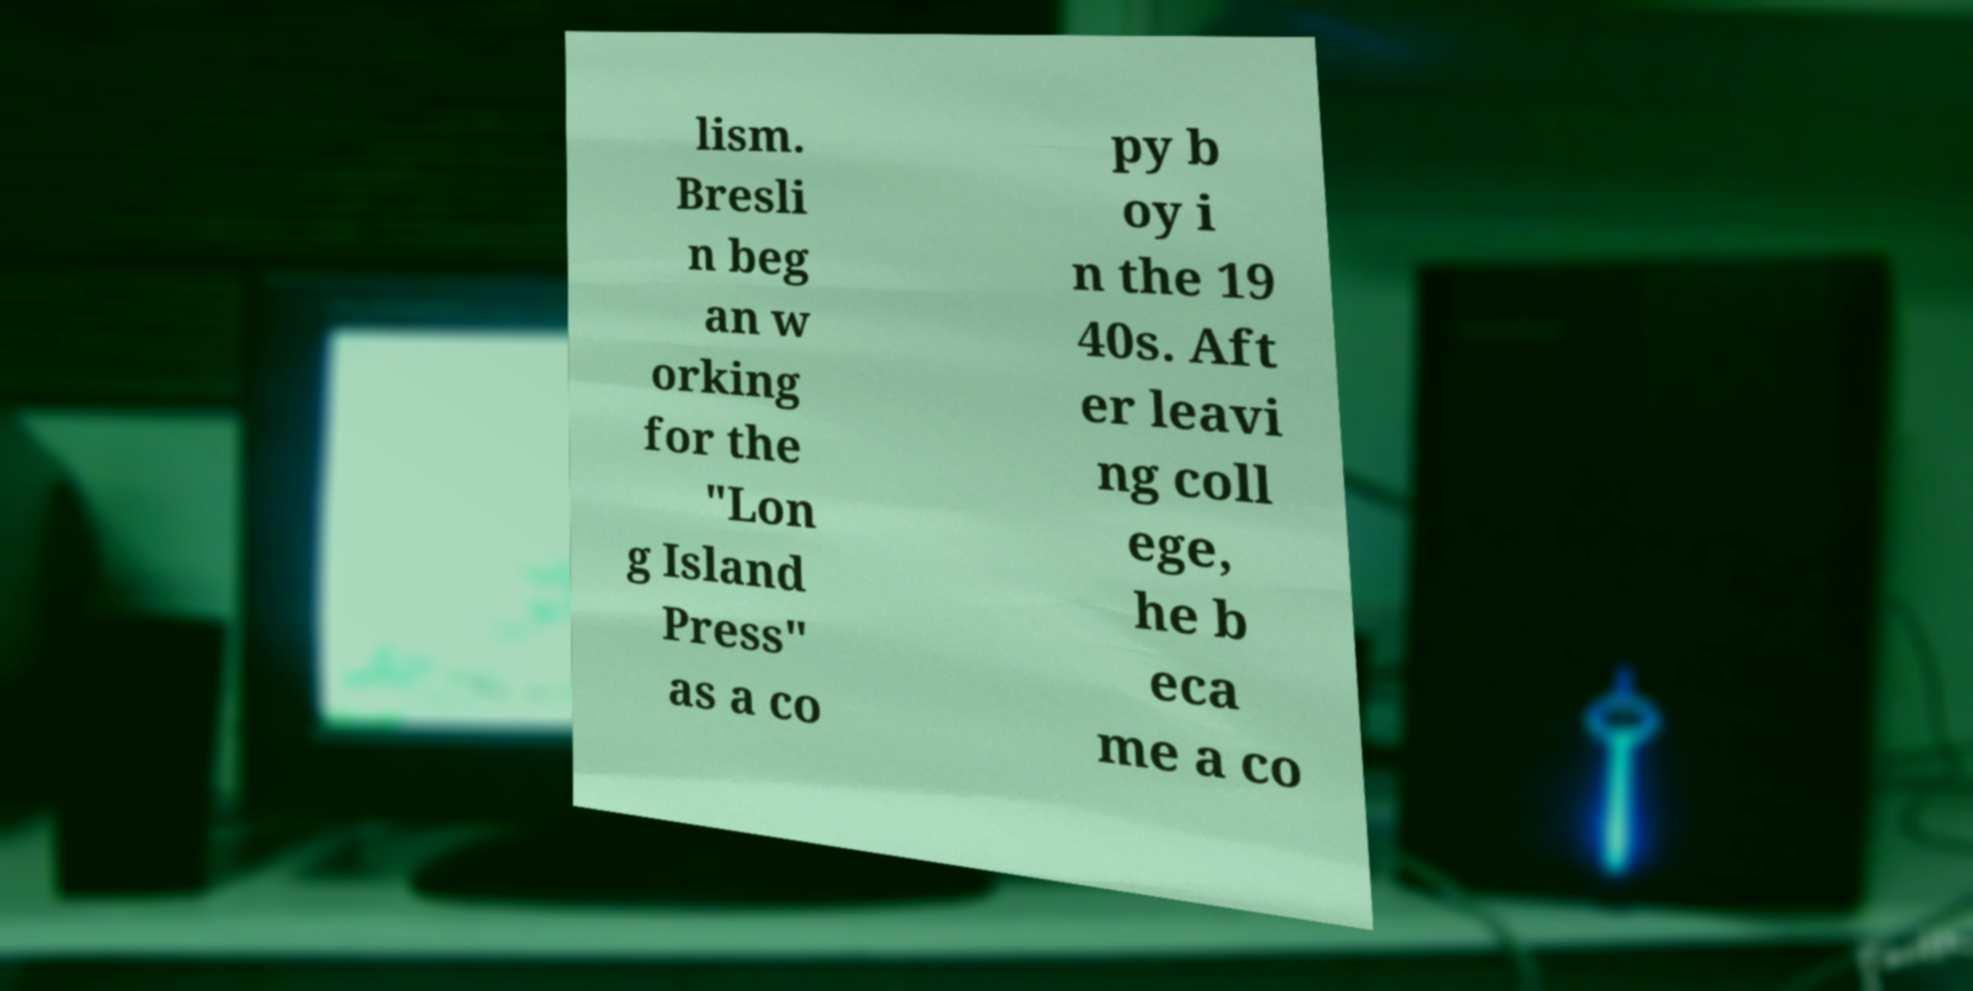Could you assist in decoding the text presented in this image and type it out clearly? lism. Bresli n beg an w orking for the "Lon g Island Press" as a co py b oy i n the 19 40s. Aft er leavi ng coll ege, he b eca me a co 